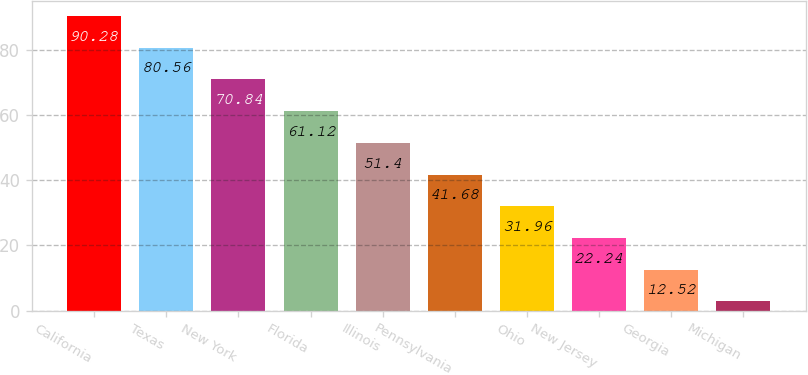<chart> <loc_0><loc_0><loc_500><loc_500><bar_chart><fcel>California<fcel>Texas<fcel>New York<fcel>Florida<fcel>Illinois<fcel>Pennsylvania<fcel>Ohio<fcel>New Jersey<fcel>Georgia<fcel>Michigan<nl><fcel>90.28<fcel>80.56<fcel>70.84<fcel>61.12<fcel>51.4<fcel>41.68<fcel>31.96<fcel>22.24<fcel>12.52<fcel>2.8<nl></chart> 